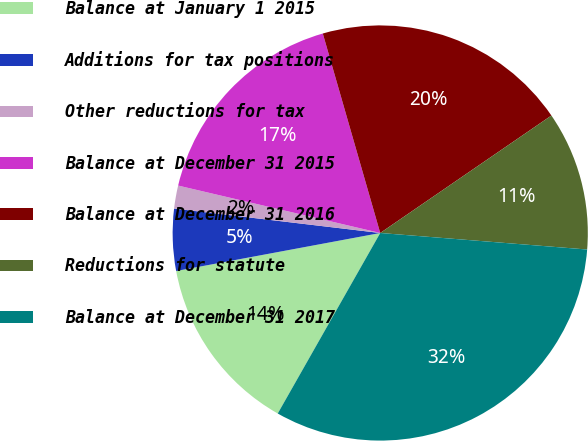Convert chart to OTSL. <chart><loc_0><loc_0><loc_500><loc_500><pie_chart><fcel>Balance at January 1 2015<fcel>Additions for tax positions<fcel>Other reductions for tax<fcel>Balance at December 31 2015<fcel>Balance at December 31 2016<fcel>Reductions for statute<fcel>Balance at December 31 2017<nl><fcel>13.85%<fcel>4.81%<fcel>1.79%<fcel>16.87%<fcel>19.89%<fcel>10.84%<fcel>31.95%<nl></chart> 